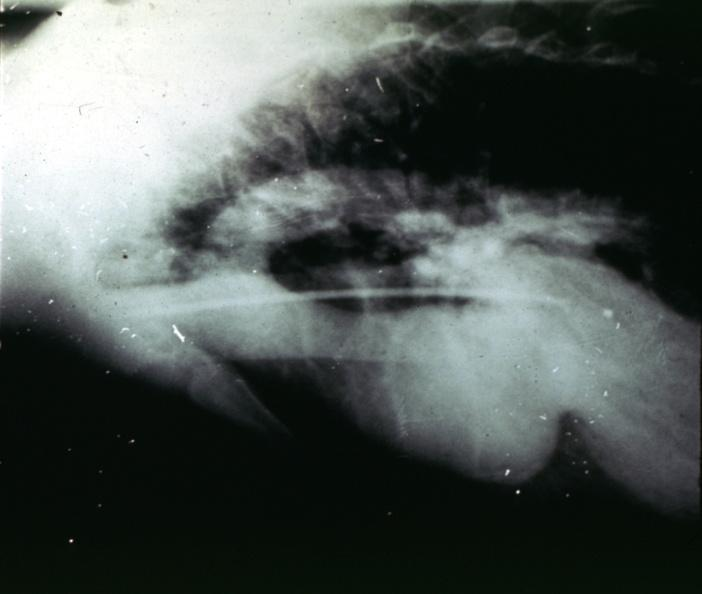s aorta present?
Answer the question using a single word or phrase. Yes 